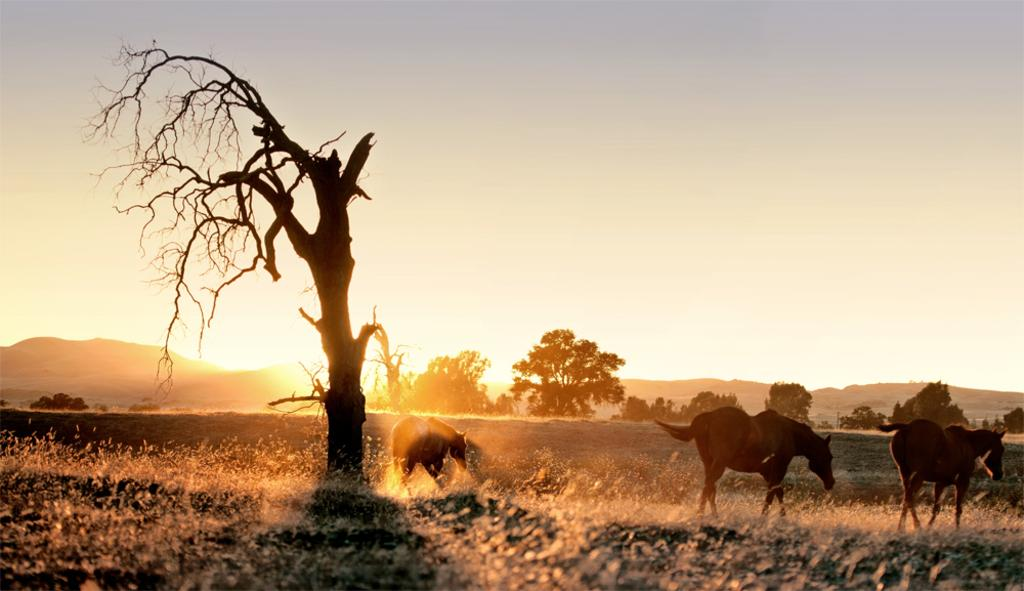What is one of the main subjects in the image? There is a tree in the image. What other living creatures can be seen in the image? There are horses in the image. What can be seen in the background of the image? There are trees and mountains in the background of the image. What is visible at the top of the image? The sky is visible at the top of the image. How many pigs are running through the wilderness in the image? There are no pigs or wilderness present in the image. What is the increase in the number of trees in the background of the image? There is no information about an increase in the number of trees in the image; it only shows the current state of the trees. 